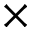<formula> <loc_0><loc_0><loc_500><loc_500>\times</formula> 